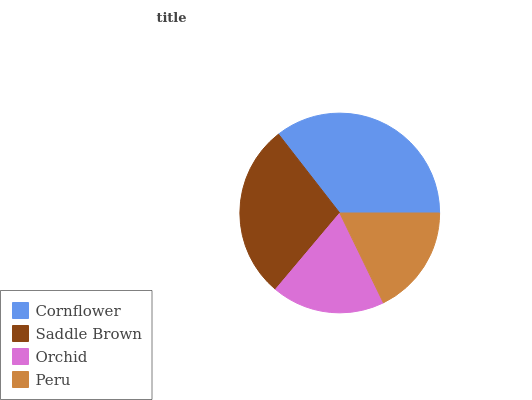Is Peru the minimum?
Answer yes or no. Yes. Is Cornflower the maximum?
Answer yes or no. Yes. Is Saddle Brown the minimum?
Answer yes or no. No. Is Saddle Brown the maximum?
Answer yes or no. No. Is Cornflower greater than Saddle Brown?
Answer yes or no. Yes. Is Saddle Brown less than Cornflower?
Answer yes or no. Yes. Is Saddle Brown greater than Cornflower?
Answer yes or no. No. Is Cornflower less than Saddle Brown?
Answer yes or no. No. Is Saddle Brown the high median?
Answer yes or no. Yes. Is Orchid the low median?
Answer yes or no. Yes. Is Orchid the high median?
Answer yes or no. No. Is Cornflower the low median?
Answer yes or no. No. 